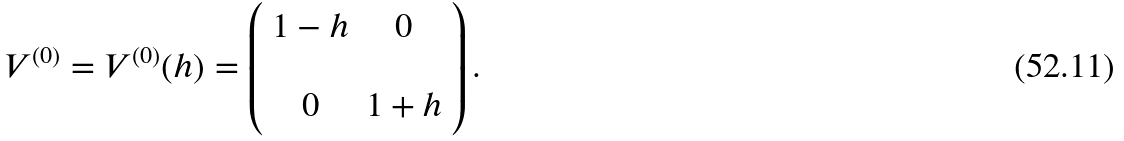Convert formula to latex. <formula><loc_0><loc_0><loc_500><loc_500>V ^ { ( 0 ) } = V ^ { ( 0 ) } ( h ) = \left ( \begin{array} { c c } 1 - h & 0 \\ \\ 0 & 1 + h \end{array} \right ) .</formula> 